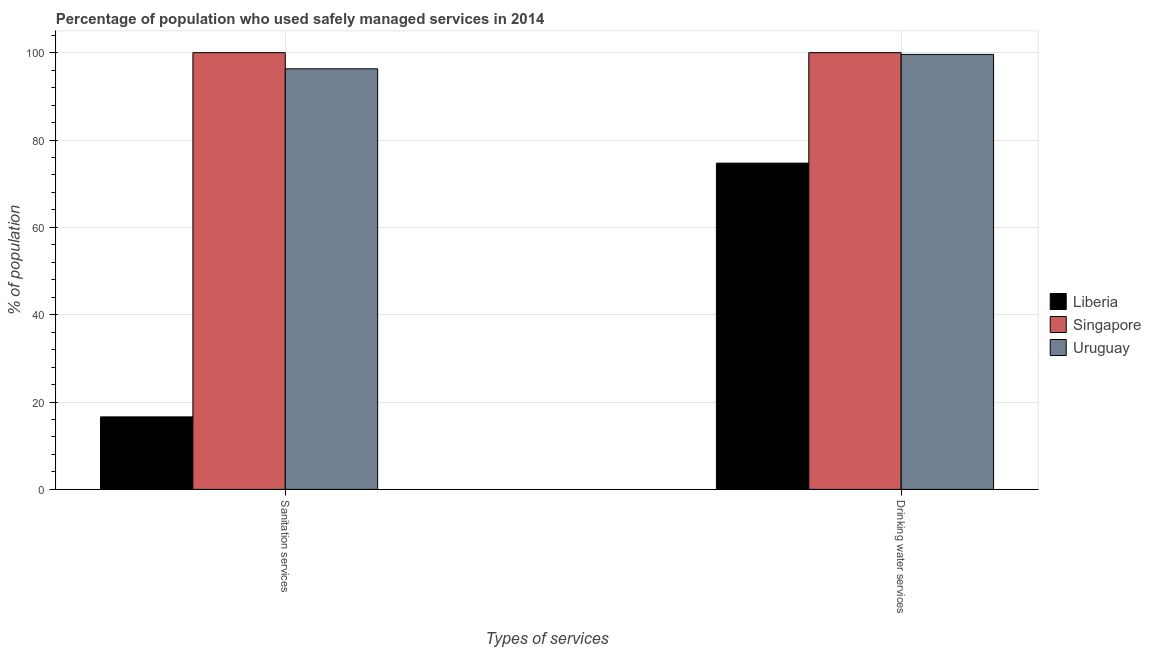How many different coloured bars are there?
Your answer should be compact. 3. How many groups of bars are there?
Keep it short and to the point. 2. Are the number of bars on each tick of the X-axis equal?
Ensure brevity in your answer.  Yes. What is the label of the 1st group of bars from the left?
Make the answer very short. Sanitation services. Across all countries, what is the maximum percentage of population who used sanitation services?
Ensure brevity in your answer.  100. Across all countries, what is the minimum percentage of population who used drinking water services?
Provide a succinct answer. 74.7. In which country was the percentage of population who used sanitation services maximum?
Ensure brevity in your answer.  Singapore. In which country was the percentage of population who used sanitation services minimum?
Offer a terse response. Liberia. What is the total percentage of population who used sanitation services in the graph?
Provide a succinct answer. 212.9. What is the difference between the percentage of population who used drinking water services in Uruguay and that in Singapore?
Your answer should be compact. -0.4. What is the difference between the percentage of population who used sanitation services in Uruguay and the percentage of population who used drinking water services in Liberia?
Your answer should be compact. 21.6. What is the average percentage of population who used drinking water services per country?
Your answer should be very brief. 91.43. What is the difference between the percentage of population who used drinking water services and percentage of population who used sanitation services in Liberia?
Provide a succinct answer. 58.1. What is the ratio of the percentage of population who used sanitation services in Uruguay to that in Liberia?
Your answer should be very brief. 5.8. What does the 3rd bar from the left in Drinking water services represents?
Your answer should be compact. Uruguay. What does the 3rd bar from the right in Sanitation services represents?
Ensure brevity in your answer.  Liberia. Does the graph contain any zero values?
Ensure brevity in your answer.  No. Does the graph contain grids?
Offer a very short reply. Yes. How are the legend labels stacked?
Provide a short and direct response. Vertical. What is the title of the graph?
Your response must be concise. Percentage of population who used safely managed services in 2014. Does "Paraguay" appear as one of the legend labels in the graph?
Make the answer very short. No. What is the label or title of the X-axis?
Ensure brevity in your answer.  Types of services. What is the label or title of the Y-axis?
Your answer should be compact. % of population. What is the % of population in Singapore in Sanitation services?
Your response must be concise. 100. What is the % of population of Uruguay in Sanitation services?
Your answer should be very brief. 96.3. What is the % of population in Liberia in Drinking water services?
Your answer should be compact. 74.7. What is the % of population in Uruguay in Drinking water services?
Ensure brevity in your answer.  99.6. Across all Types of services, what is the maximum % of population of Liberia?
Keep it short and to the point. 74.7. Across all Types of services, what is the maximum % of population in Uruguay?
Give a very brief answer. 99.6. Across all Types of services, what is the minimum % of population of Singapore?
Your answer should be very brief. 100. Across all Types of services, what is the minimum % of population of Uruguay?
Make the answer very short. 96.3. What is the total % of population in Liberia in the graph?
Ensure brevity in your answer.  91.3. What is the total % of population in Uruguay in the graph?
Make the answer very short. 195.9. What is the difference between the % of population of Liberia in Sanitation services and that in Drinking water services?
Make the answer very short. -58.1. What is the difference between the % of population in Liberia in Sanitation services and the % of population in Singapore in Drinking water services?
Keep it short and to the point. -83.4. What is the difference between the % of population of Liberia in Sanitation services and the % of population of Uruguay in Drinking water services?
Your answer should be compact. -83. What is the average % of population of Liberia per Types of services?
Your answer should be compact. 45.65. What is the average % of population in Singapore per Types of services?
Your response must be concise. 100. What is the average % of population in Uruguay per Types of services?
Ensure brevity in your answer.  97.95. What is the difference between the % of population of Liberia and % of population of Singapore in Sanitation services?
Your answer should be very brief. -83.4. What is the difference between the % of population in Liberia and % of population in Uruguay in Sanitation services?
Give a very brief answer. -79.7. What is the difference between the % of population in Singapore and % of population in Uruguay in Sanitation services?
Ensure brevity in your answer.  3.7. What is the difference between the % of population in Liberia and % of population in Singapore in Drinking water services?
Offer a very short reply. -25.3. What is the difference between the % of population of Liberia and % of population of Uruguay in Drinking water services?
Ensure brevity in your answer.  -24.9. What is the difference between the % of population of Singapore and % of population of Uruguay in Drinking water services?
Your answer should be very brief. 0.4. What is the ratio of the % of population of Liberia in Sanitation services to that in Drinking water services?
Your answer should be very brief. 0.22. What is the ratio of the % of population of Singapore in Sanitation services to that in Drinking water services?
Give a very brief answer. 1. What is the ratio of the % of population of Uruguay in Sanitation services to that in Drinking water services?
Offer a very short reply. 0.97. What is the difference between the highest and the second highest % of population in Liberia?
Your response must be concise. 58.1. What is the difference between the highest and the second highest % of population in Singapore?
Offer a terse response. 0. What is the difference between the highest and the lowest % of population of Liberia?
Provide a succinct answer. 58.1. What is the difference between the highest and the lowest % of population of Singapore?
Your answer should be very brief. 0. 